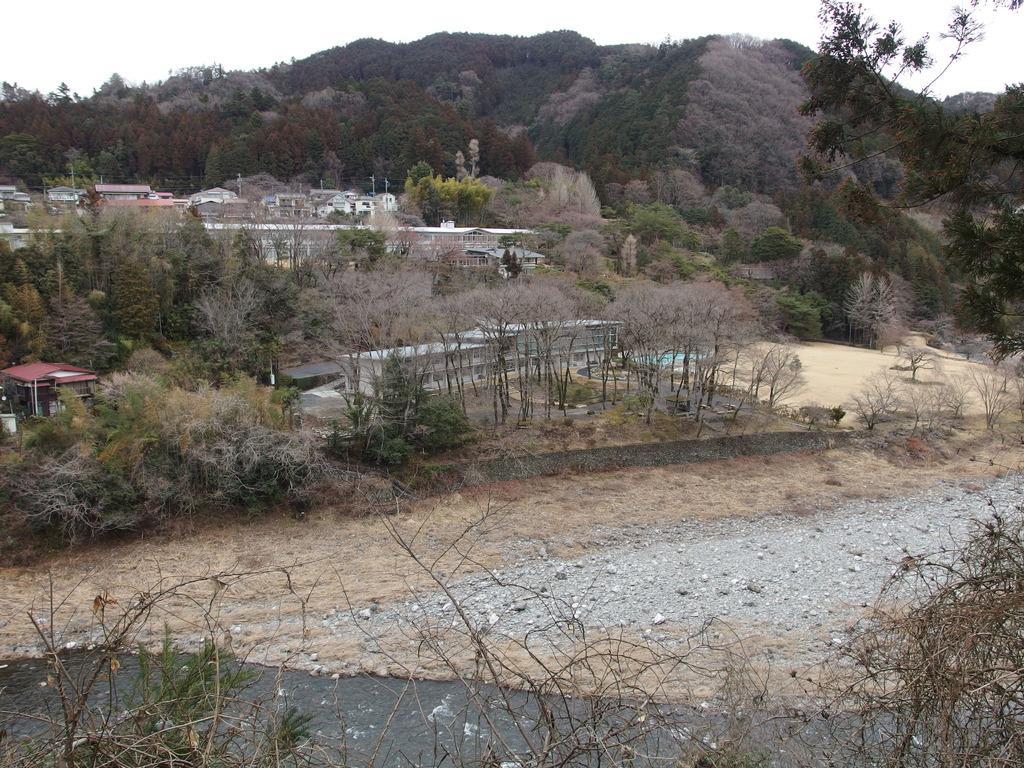How would you summarize this image in a sentence or two? In this image in front there is water. There is mud. In the background of the image there are trees, buildings and sky. 